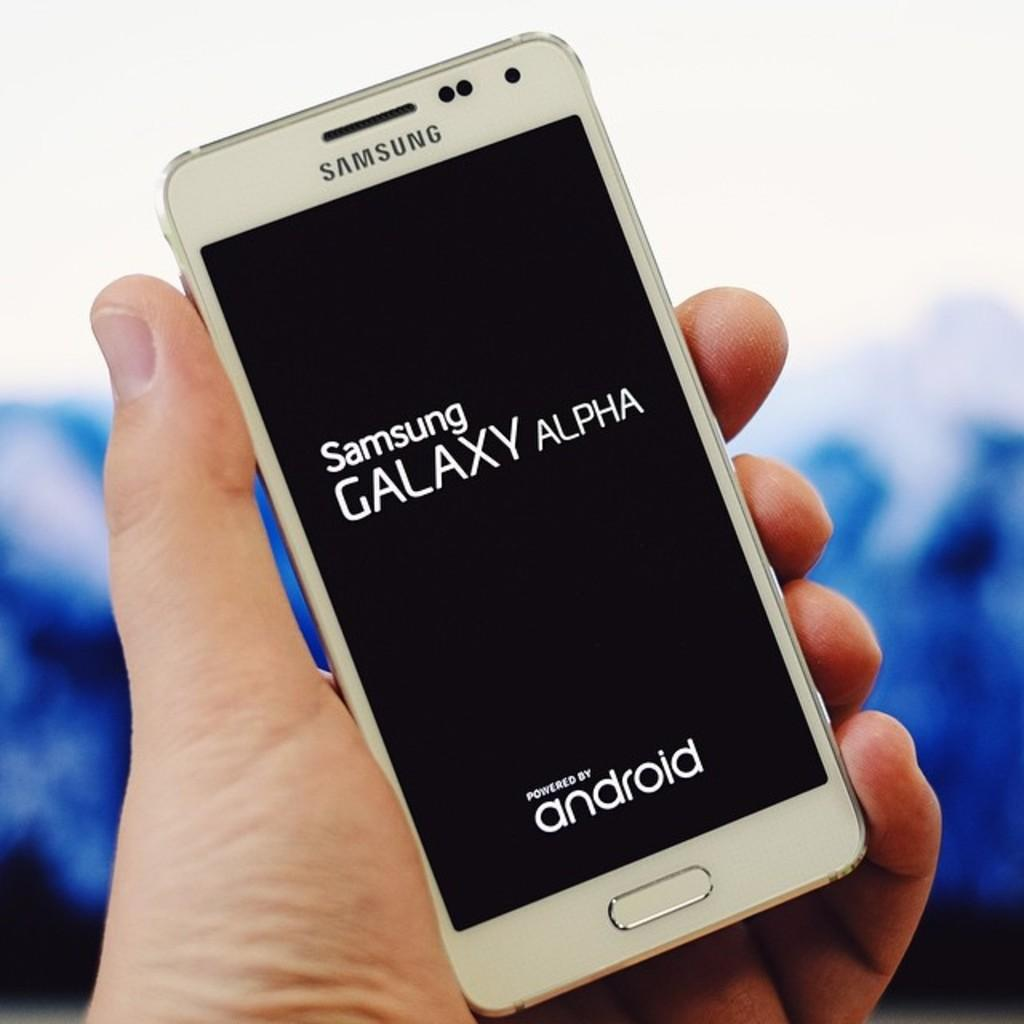<image>
Give a short and clear explanation of the subsequent image. hand holding a samsung galaxy alpha phone powered by android 